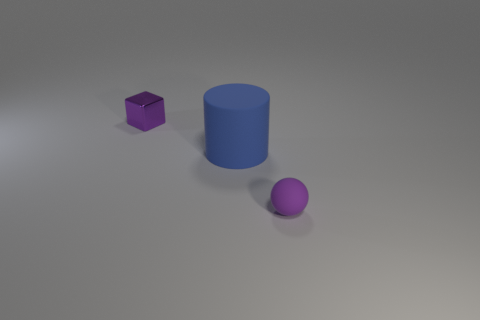Can you tell me the colors of the objects in the image from left to right? From left to right, the objects' colors are purple, blue, and light purple. The purple object is a small cube, the blue object is a cylinder, and the light purple object is a small ball. 